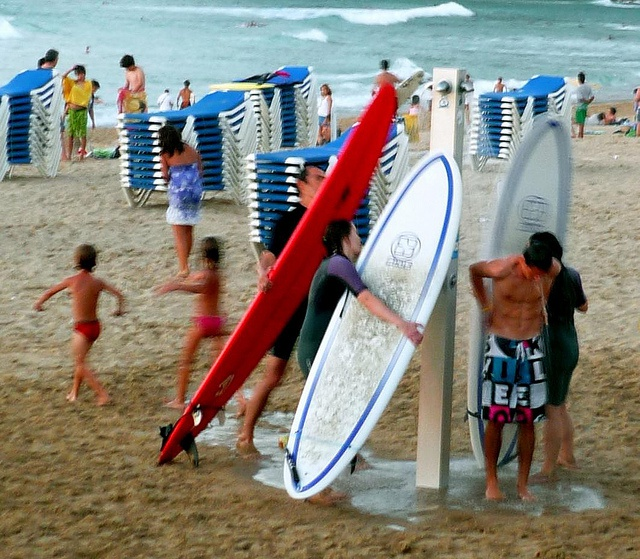Describe the objects in this image and their specific colors. I can see surfboard in lightblue, lightgray, and darkgray tones, surfboard in lightblue, maroon, red, and black tones, people in lightblue, black, maroon, and gray tones, surfboard in lightblue, darkgray, gray, and black tones, and people in lightblue, darkgray, lightgray, and gray tones in this image. 